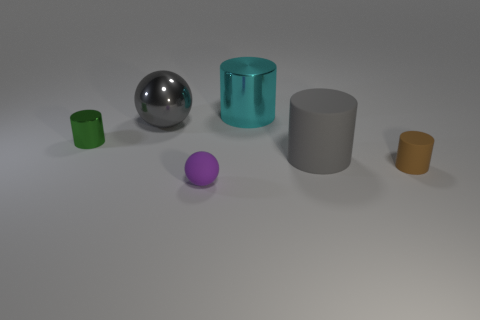Add 3 small green shiny cylinders. How many objects exist? 9 Subtract all green metallic cylinders. How many cylinders are left? 3 Subtract all cylinders. How many objects are left? 2 Subtract 1 balls. How many balls are left? 1 Subtract all brown spheres. Subtract all yellow blocks. How many spheres are left? 2 Subtract all big cyan metallic cylinders. Subtract all small matte spheres. How many objects are left? 4 Add 3 small green metallic things. How many small green metallic things are left? 4 Add 5 big gray rubber balls. How many big gray rubber balls exist? 5 Subtract all cyan cylinders. How many cylinders are left? 3 Subtract 1 purple spheres. How many objects are left? 5 